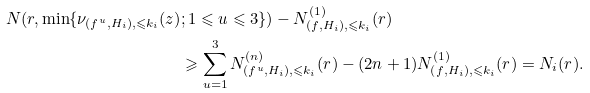Convert formula to latex. <formula><loc_0><loc_0><loc_500><loc_500>N ( r , \min \{ \nu _ { ( f ^ { u } , H _ { i } ) , \leqslant k _ { i } } ( z ) & ; 1 \leqslant u \leqslant 3 \} ) - N ^ { ( 1 ) } _ { ( f , H _ { i } ) , \leqslant k _ { i } } ( r ) \\ & \geqslant \sum _ { u = 1 } ^ { 3 } N ^ { ( n ) } _ { ( f ^ { u } , H _ { i } ) , \leqslant k _ { i } } ( r ) - ( 2 n + 1 ) N ^ { ( 1 ) } _ { ( f , H _ { i } ) , \leqslant k _ { i } } ( r ) = N _ { i } ( r ) .</formula> 